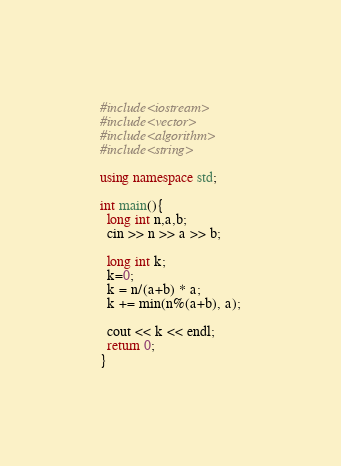<code> <loc_0><loc_0><loc_500><loc_500><_C++_>#include<iostream>
#include<vector>
#include<algorithm>
#include<string>

using namespace std;

int main(){
  long int n,a,b;
  cin >> n >> a >> b;

  long int k;
  k=0;
  k = n/(a+b) * a;
  k += min(n%(a+b), a);

  cout << k << endl;
  return 0;
}</code> 